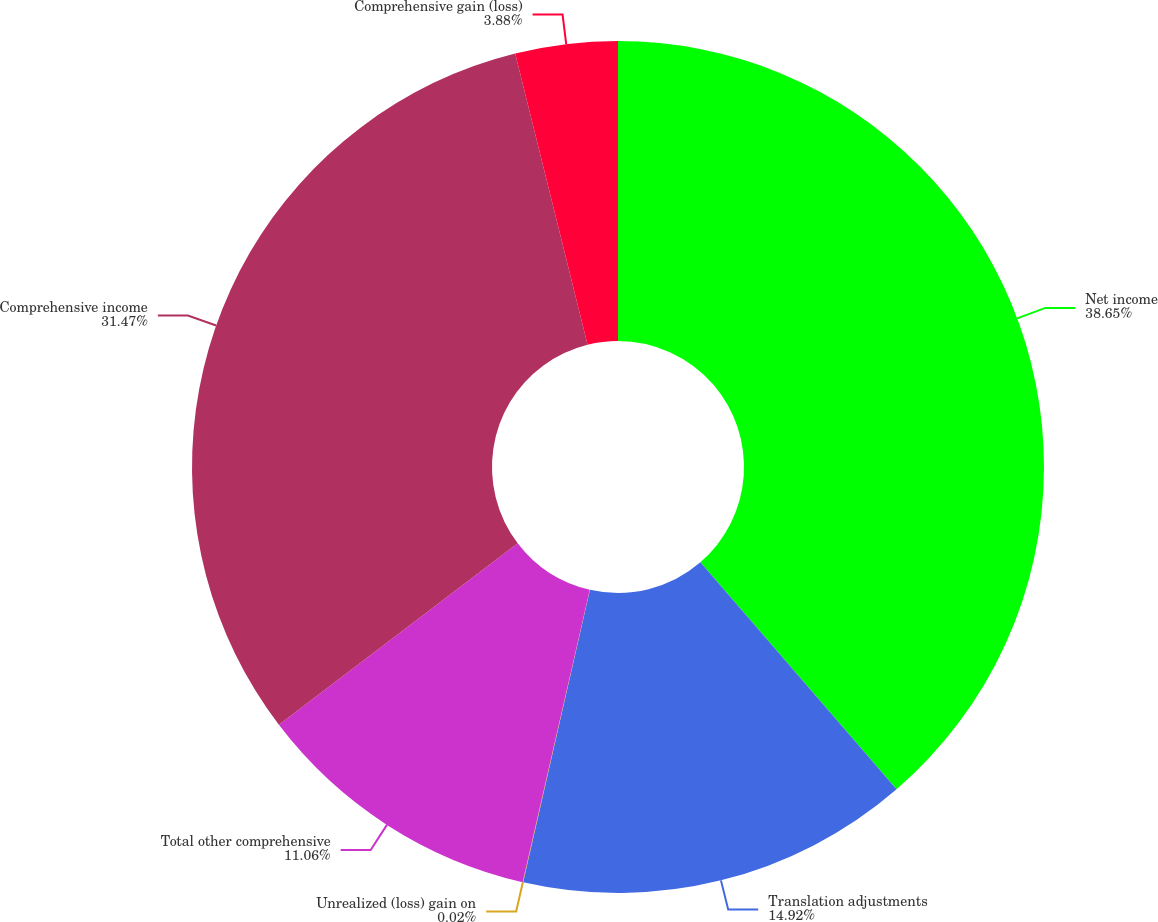<chart> <loc_0><loc_0><loc_500><loc_500><pie_chart><fcel>Net income<fcel>Translation adjustments<fcel>Unrealized (loss) gain on<fcel>Total other comprehensive<fcel>Comprehensive income<fcel>Comprehensive gain (loss)<nl><fcel>38.66%<fcel>14.92%<fcel>0.02%<fcel>11.06%<fcel>31.47%<fcel>3.88%<nl></chart> 